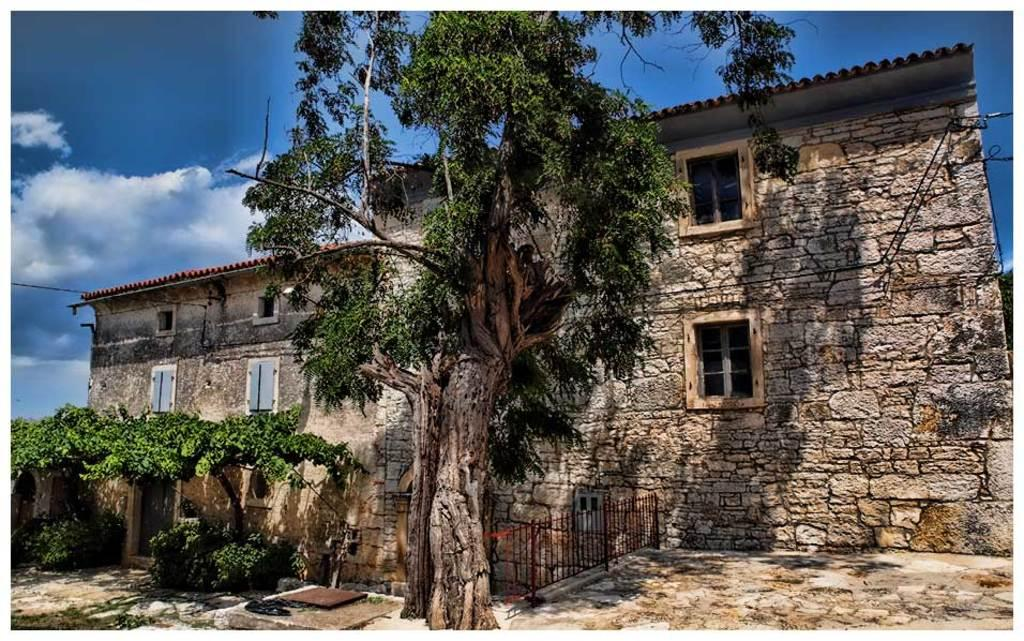What type of structure is visible in the image? There is a house with windows in the image. What other natural elements can be seen in the image? There are plants and a tree visible in the image. What is visible in the background of the image? The sky is visible in the background of the image, along with clouds. What type of territory is being claimed by the plants in the image? There is no indication in the image that the plants are claiming any territory. 